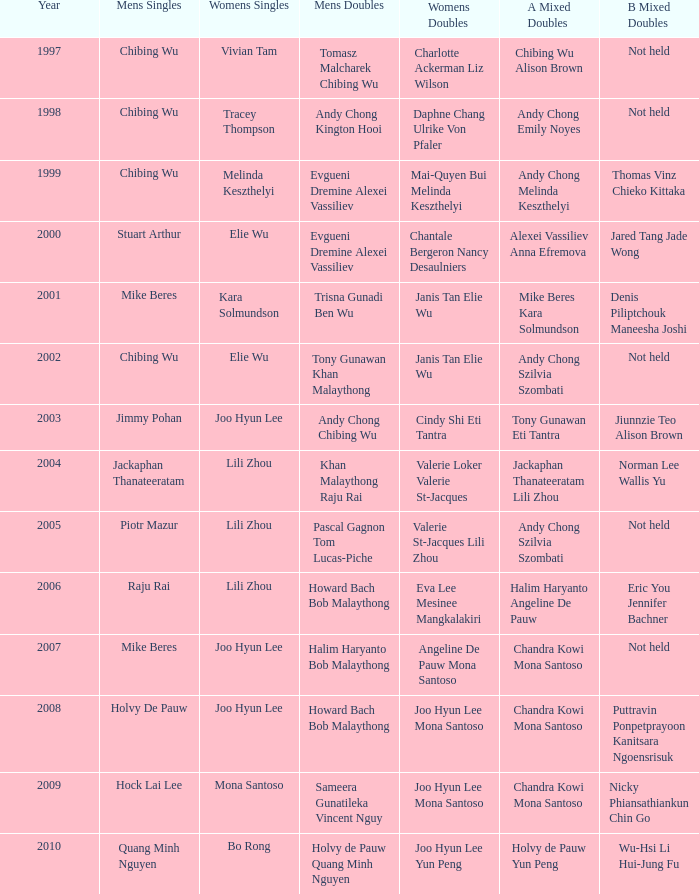What is the earliest year when men's singles is raju rai? 2006.0. 